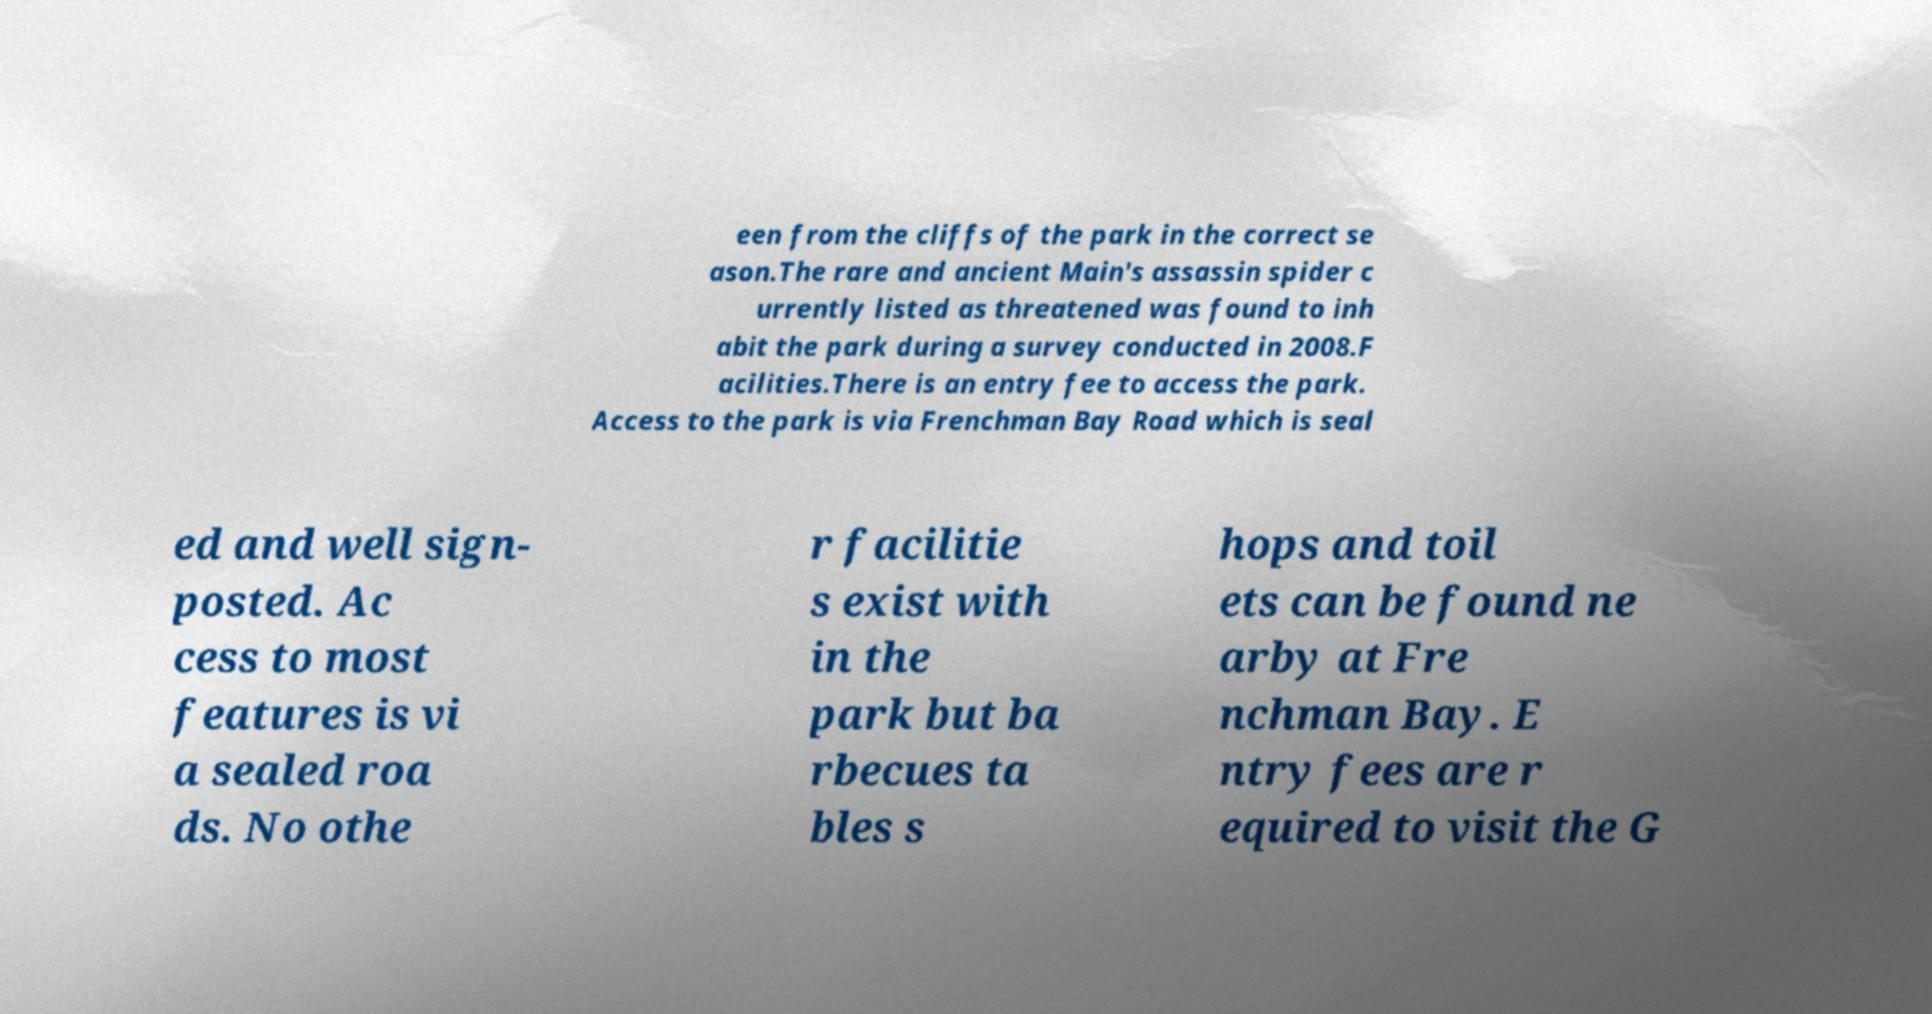Could you extract and type out the text from this image? een from the cliffs of the park in the correct se ason.The rare and ancient Main's assassin spider c urrently listed as threatened was found to inh abit the park during a survey conducted in 2008.F acilities.There is an entry fee to access the park. Access to the park is via Frenchman Bay Road which is seal ed and well sign- posted. Ac cess to most features is vi a sealed roa ds. No othe r facilitie s exist with in the park but ba rbecues ta bles s hops and toil ets can be found ne arby at Fre nchman Bay. E ntry fees are r equired to visit the G 